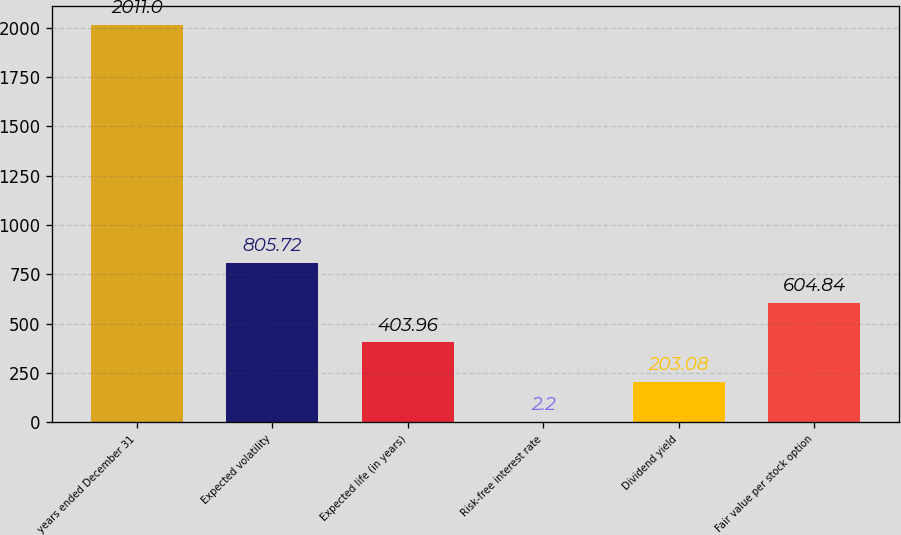<chart> <loc_0><loc_0><loc_500><loc_500><bar_chart><fcel>years ended December 31<fcel>Expected volatility<fcel>Expected life (in years)<fcel>Risk-free interest rate<fcel>Dividend yield<fcel>Fair value per stock option<nl><fcel>2011<fcel>805.72<fcel>403.96<fcel>2.2<fcel>203.08<fcel>604.84<nl></chart> 